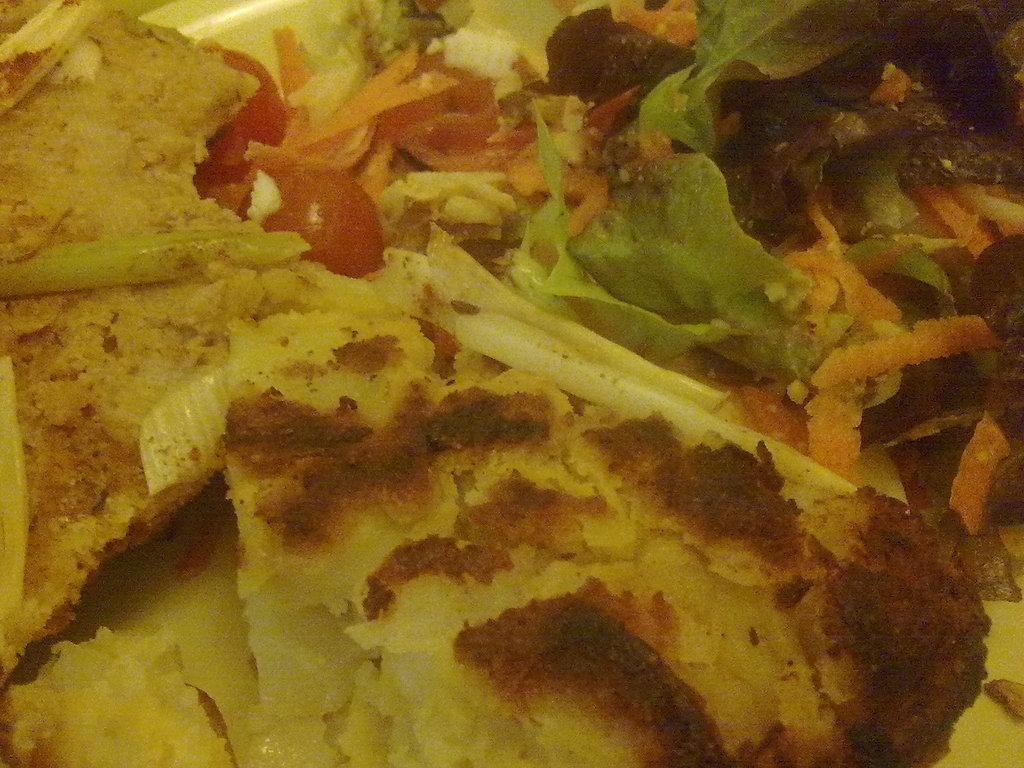What is present in the image? There is food in the image. What story is being told by the food in the image? There is no story being told by the food in the image; it is simply a representation of food. 